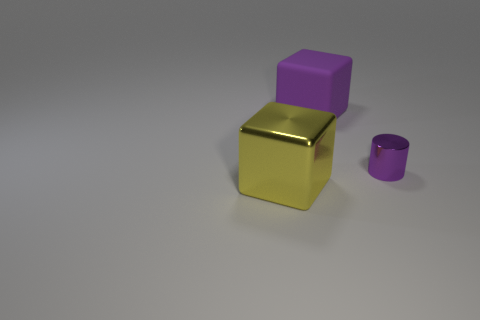Add 2 tiny cylinders. How many objects exist? 5 Subtract all cylinders. How many objects are left? 2 Add 3 rubber cylinders. How many rubber cylinders exist? 3 Subtract 1 purple cubes. How many objects are left? 2 Subtract all rubber cubes. Subtract all tiny objects. How many objects are left? 1 Add 1 purple cylinders. How many purple cylinders are left? 2 